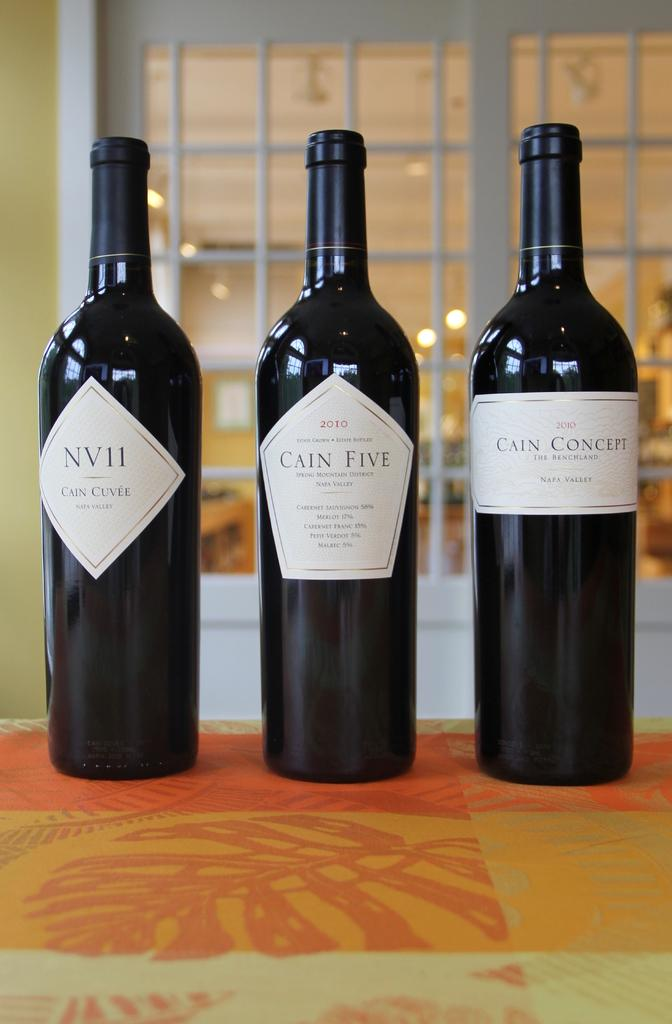Provide a one-sentence caption for the provided image. Wine labels give information about the alcohol % and type of wine that is in the bottle. 